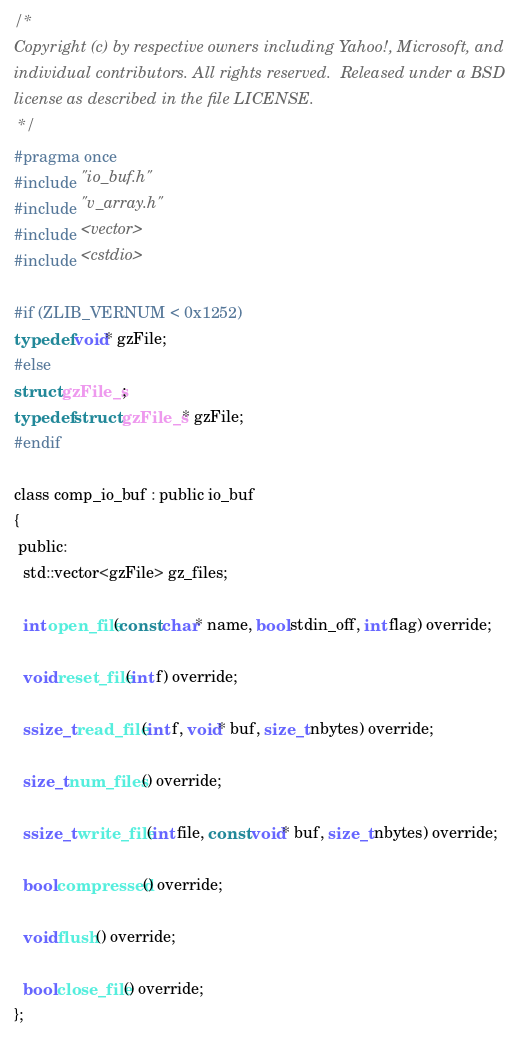<code> <loc_0><loc_0><loc_500><loc_500><_C_>/*
Copyright (c) by respective owners including Yahoo!, Microsoft, and
individual contributors. All rights reserved.  Released under a BSD
license as described in the file LICENSE.
 */
#pragma once
#include "io_buf.h"
#include "v_array.h"
#include <vector>
#include <cstdio>

#if (ZLIB_VERNUM < 0x1252)
typedef void* gzFile;
#else
struct gzFile_s;
typedef struct gzFile_s* gzFile;
#endif

class comp_io_buf : public io_buf
{
 public:
  std::vector<gzFile> gz_files;

  int open_file(const char* name, bool stdin_off, int flag) override;

  void reset_file(int f) override;

  ssize_t read_file(int f, void* buf, size_t nbytes) override;

  size_t num_files() override;

  ssize_t write_file(int file, const void* buf, size_t nbytes) override;

  bool compressed() override;

  void flush() override;

  bool close_file() override;
};
</code> 